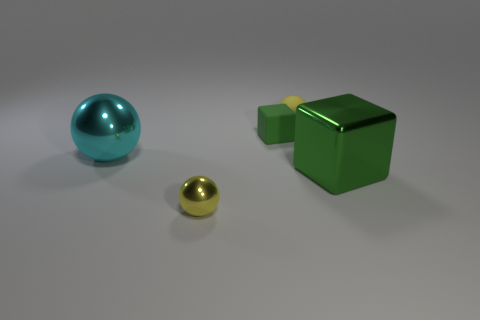There is another cube that is the same color as the tiny block; what is its material?
Provide a succinct answer. Metal. How many small things are cyan spheres or green metallic things?
Offer a very short reply. 0. The yellow thing that is in front of the tiny matte ball has what shape?
Offer a very short reply. Sphere. Are there any large balls of the same color as the metal cube?
Give a very brief answer. No. Does the green thing on the right side of the tiny yellow rubber object have the same size as the green matte cube behind the small yellow metal ball?
Make the answer very short. No. Are there more metal blocks that are left of the small shiny sphere than rubber cubes behind the small matte sphere?
Your answer should be very brief. No. Are there any large balls made of the same material as the big block?
Your answer should be very brief. Yes. Do the matte block and the big metallic cube have the same color?
Your answer should be very brief. Yes. There is a ball that is in front of the green matte object and behind the large green metallic block; what is its material?
Offer a very short reply. Metal. What is the color of the big cube?
Give a very brief answer. Green. 